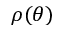Convert formula to latex. <formula><loc_0><loc_0><loc_500><loc_500>\rho ( \theta )</formula> 